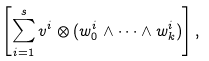<formula> <loc_0><loc_0><loc_500><loc_500>\left [ \sum _ { i = 1 } ^ { s } v ^ { i } \otimes ( w _ { 0 } ^ { i } \wedge \dots \wedge w _ { k } ^ { i } ) \right ] ,</formula> 